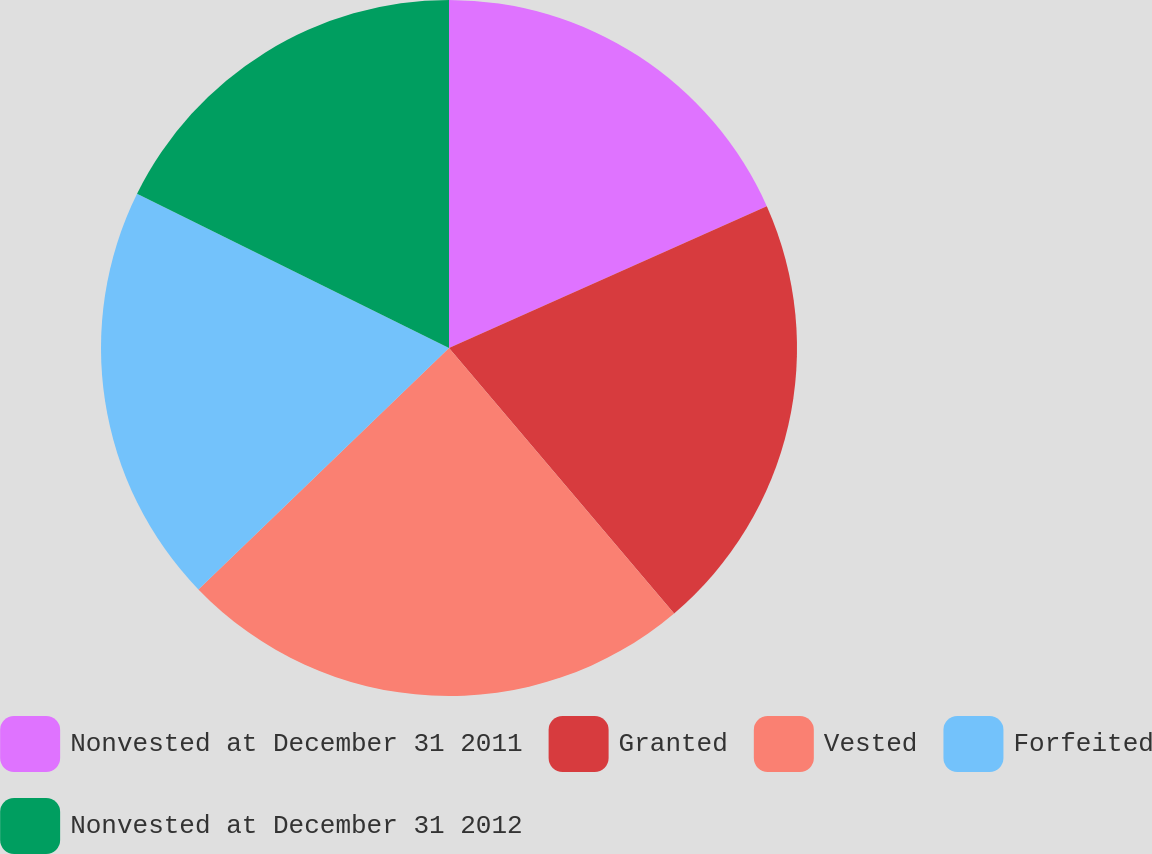Convert chart. <chart><loc_0><loc_0><loc_500><loc_500><pie_chart><fcel>Nonvested at December 31 2011<fcel>Granted<fcel>Vested<fcel>Forfeited<fcel>Nonvested at December 31 2012<nl><fcel>18.32%<fcel>20.48%<fcel>23.99%<fcel>19.51%<fcel>17.69%<nl></chart> 